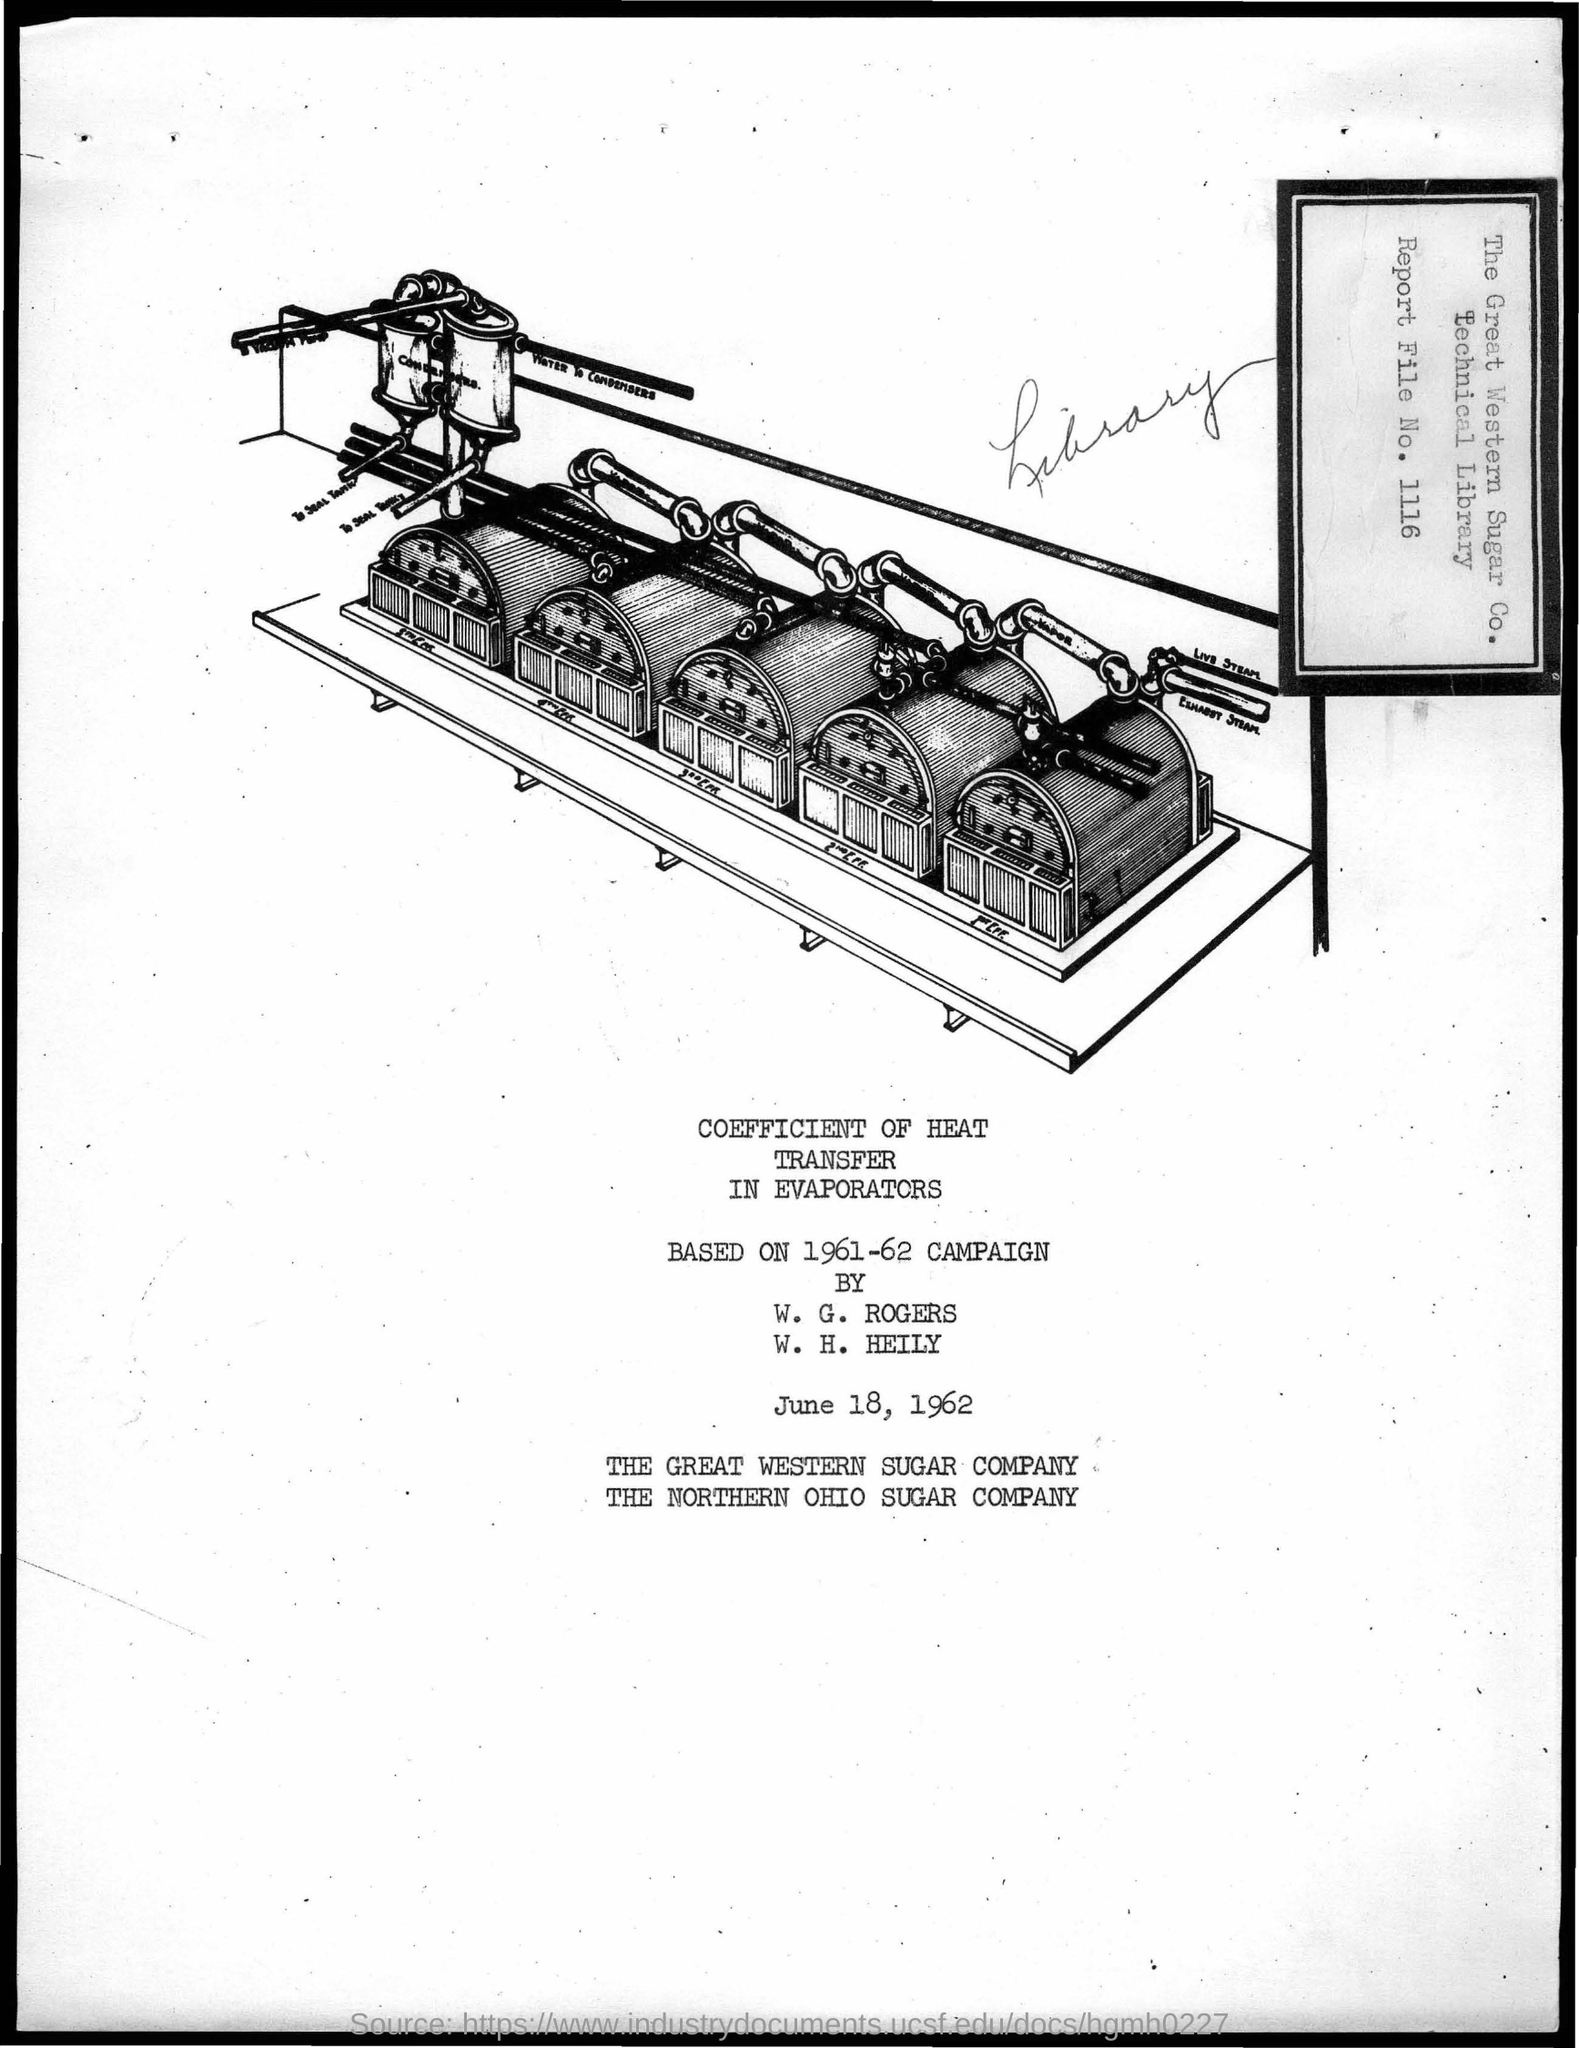What is the report file  number ?
Keep it short and to the point. 1116. What is the date mentioned in the below document ?
Keep it short and to the point. June 18, 1962. 